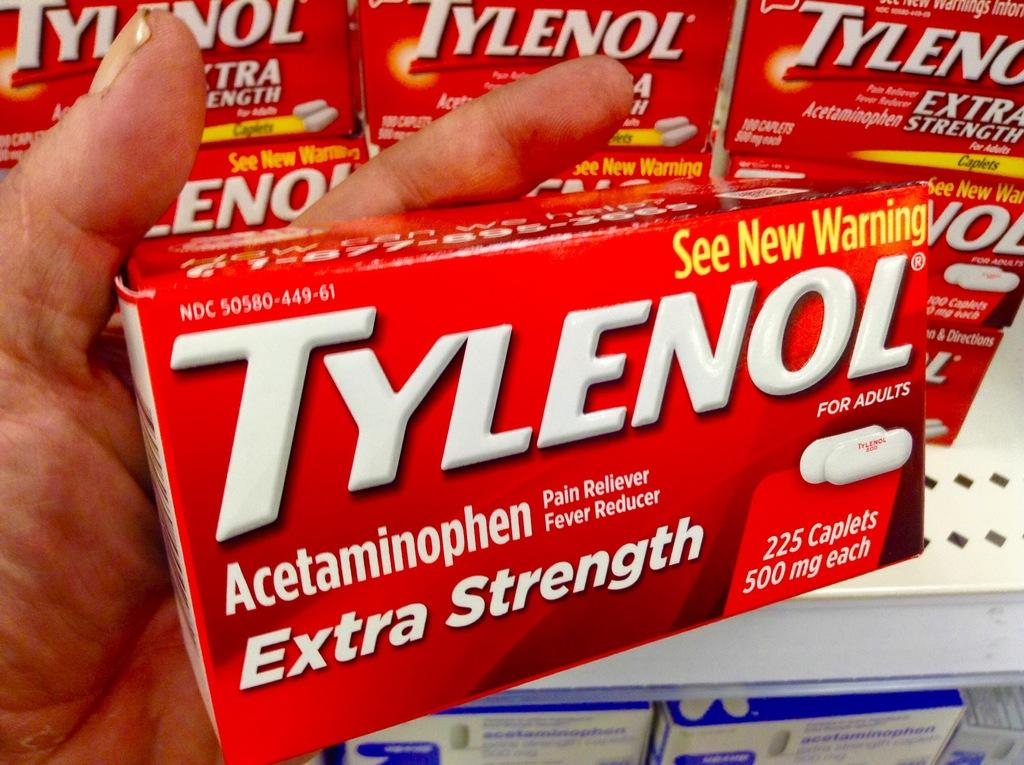What color are the boxes in the image? The boxes in the image are red. What information is written on the boxes? The name is written on the boxes. What is the person in the image doing with a box? One person is holding a box. What type of storage or display is present in the image? There are white color racks in the image. How many boxes are visible on the white color racks? There are more boxes on the white color racks. How many eggs are present in the image? There are no eggs visible in the image. What type of servant is attending to the boxes in the image? There is no servant present in the image. 